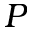Convert formula to latex. <formula><loc_0><loc_0><loc_500><loc_500>P</formula> 